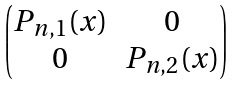<formula> <loc_0><loc_0><loc_500><loc_500>\begin{pmatrix} P _ { n , 1 } ( x ) & 0 \\ 0 & P _ { n , 2 } ( x ) \end{pmatrix}</formula> 